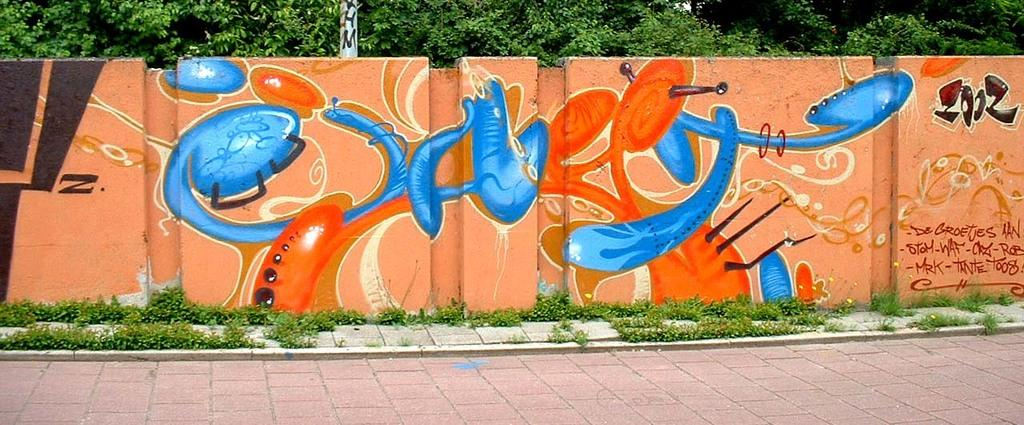What is the main subject of the image? There is a painting in the image. What else can be seen on the wall in the image? There is text on the wall in the image. What type of natural elements are visible in the image? Trees are visible in the image. What is the structure behind the wall in the image? There is a pole behind the wall in the image. What type of vegetation is present at the bottom of the image? There are plants at the bottom of the image. What type of surface is visible in the image? There is a pavement in the image. How do the hands of the people in the painting create harmony in the image? There are no people or hands visible in the painting, and therefore no such interaction can be observed. 